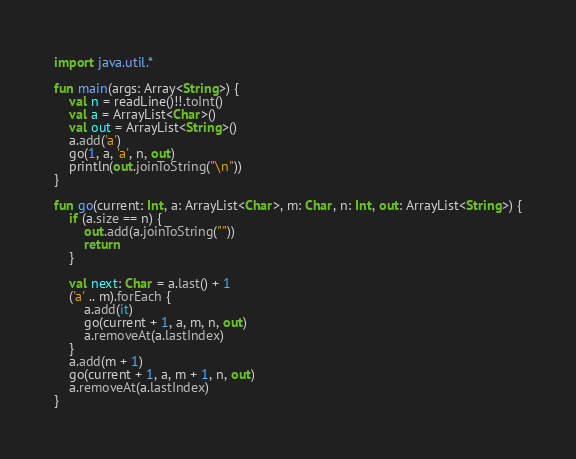Convert code to text. <code><loc_0><loc_0><loc_500><loc_500><_Kotlin_>import java.util.*

fun main(args: Array<String>) {
    val n = readLine()!!.toInt()
    val a = ArrayList<Char>()
    val out = ArrayList<String>()
    a.add('a')
    go(1, a, 'a', n, out)
    println(out.joinToString("\n"))
}

fun go(current: Int, a: ArrayList<Char>, m: Char, n: Int, out: ArrayList<String>) {
    if (a.size == n) {
        out.add(a.joinToString(""))
        return
    }

    val next: Char = a.last() + 1
    ('a' .. m).forEach {
        a.add(it)
        go(current + 1, a, m, n, out)
        a.removeAt(a.lastIndex)
    }
    a.add(m + 1)
    go(current + 1, a, m + 1, n, out)
    a.removeAt(a.lastIndex)
}</code> 